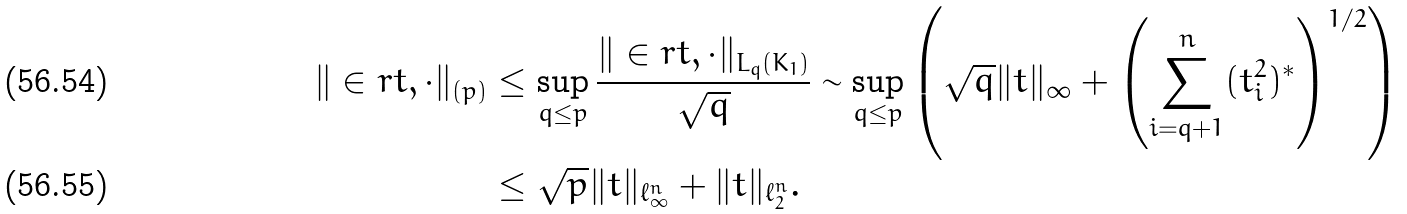Convert formula to latex. <formula><loc_0><loc_0><loc_500><loc_500>\| \in r { t , \cdot } \| _ { ( p ) } & \leq \sup _ { q \leq p } \frac { \| \in r { t , \cdot } \| _ { L _ { q } ( K _ { 1 } ) } } { \sqrt { q } } \sim \sup _ { q \leq p } \left ( \sqrt { q } \| t \| _ { \infty } + \left ( \sum _ { i = q + 1 } ^ { n } ( t _ { i } ^ { 2 } ) ^ { * } \right ) ^ { 1 / 2 } \right ) \\ & \leq \sqrt { p } \| t \| _ { \ell _ { \infty } ^ { n } } + \| t \| _ { \ell _ { 2 } ^ { n } } .</formula> 